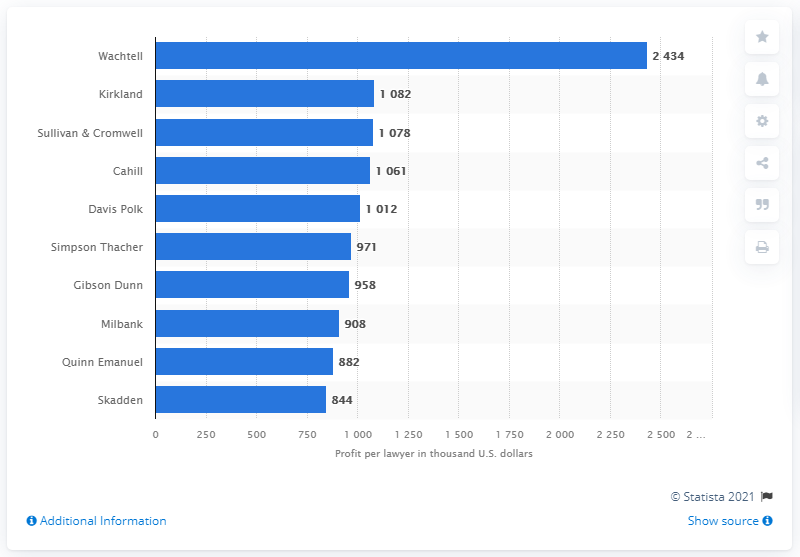Mention a couple of crucial points in this snapshot. Kirkland reported the highest profit per lawyer among all law firms in the United States in 2020. Wachtell reported the highest profit per lawyer among all law firms in the United States in 2020. 